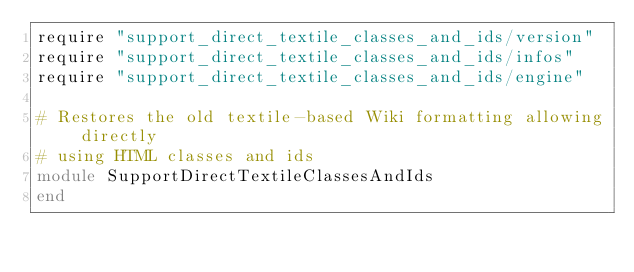<code> <loc_0><loc_0><loc_500><loc_500><_Ruby_>require "support_direct_textile_classes_and_ids/version"
require "support_direct_textile_classes_and_ids/infos"
require "support_direct_textile_classes_and_ids/engine"

# Restores the old textile-based Wiki formatting allowing directly
# using HTML classes and ids
module SupportDirectTextileClassesAndIds
end
</code> 